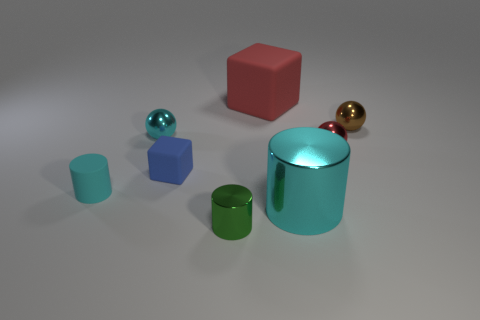Which object stands out the most to you, and why? The large cyan cylinder stands out prominently due to its size, vibrant color, and reflective surface, which distinguishes it from the other objects. Its positioning in the center of the arrangement also makes it a focal point in the composition. 